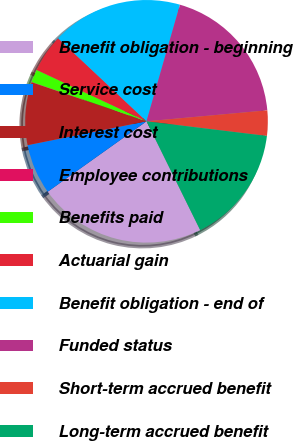Convert chart to OTSL. <chart><loc_0><loc_0><loc_500><loc_500><pie_chart><fcel>Benefit obligation - beginning<fcel>Service cost<fcel>Interest cost<fcel>Employee contributions<fcel>Benefits paid<fcel>Actuarial gain<fcel>Benefit obligation - end of<fcel>Funded status<fcel>Short-term accrued benefit<fcel>Long-term accrued benefit<nl><fcel>22.44%<fcel>6.7%<fcel>8.37%<fcel>0.04%<fcel>1.71%<fcel>5.04%<fcel>17.44%<fcel>19.11%<fcel>3.37%<fcel>15.78%<nl></chart> 